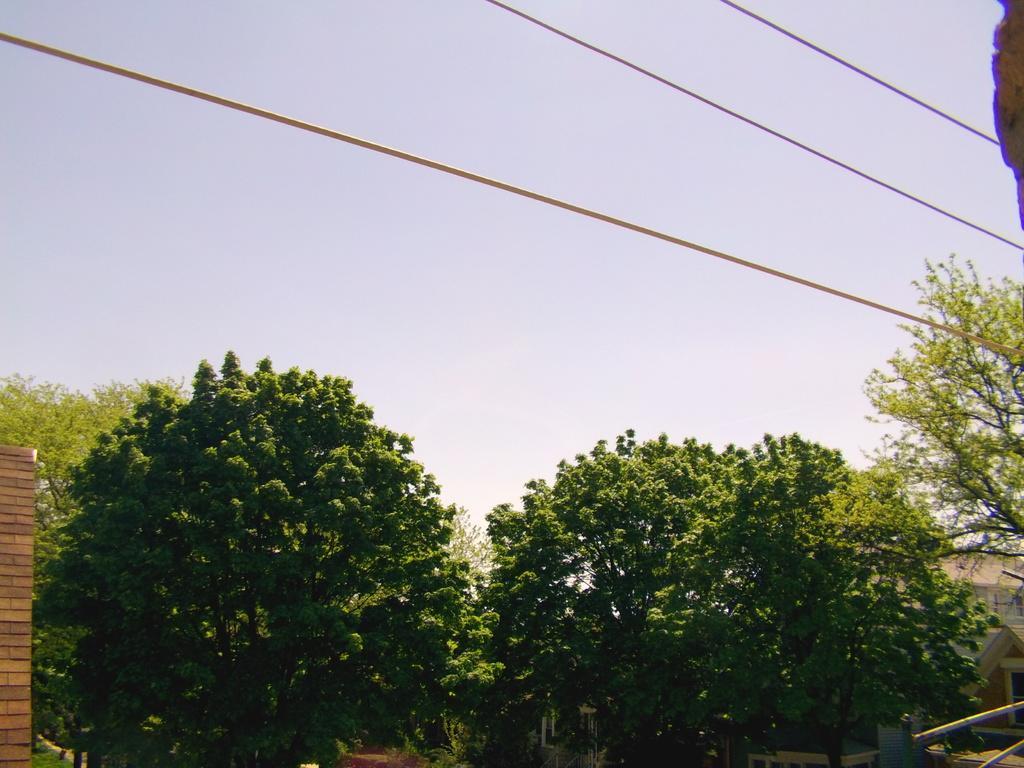Can you describe this image briefly? In this picture there are some trees. I can observe three wires. In the background there is a sky. 